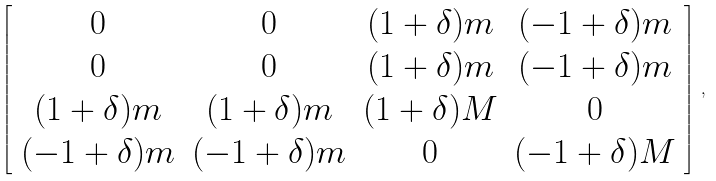Convert formula to latex. <formula><loc_0><loc_0><loc_500><loc_500>\left [ \begin{array} { c c c c } 0 & 0 & ( 1 + \delta ) m & ( - 1 + \delta ) m \\ 0 & 0 & ( 1 + \delta ) m & ( - 1 + \delta ) m \\ ( 1 + \delta ) m & ( 1 + \delta ) m & ( 1 + \delta ) M & 0 \\ ( - 1 + \delta ) m & ( - 1 + \delta ) m & 0 & ( - 1 + \delta ) M \end{array} \right ] \, ,</formula> 